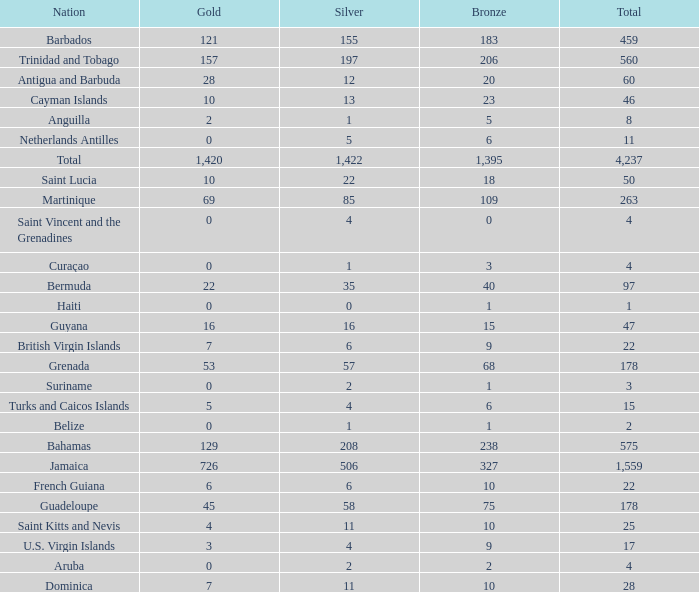What is listed as the highest Silver that also has a Gold of 4 and a Total that's larger than 25? None. 